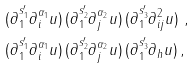Convert formula to latex. <formula><loc_0><loc_0><loc_500><loc_500>& ( \partial _ { 1 } ^ { s ^ { \prime } _ { 1 } } \partial _ { i } ^ { \alpha _ { 1 } } u ) \, ( \partial _ { 1 } ^ { s ^ { \prime } _ { 2 } } \partial _ { j } ^ { \alpha _ { 2 } } u ) \, ( \partial _ { 1 } ^ { s ^ { \prime } _ { 3 } } \partial ^ { 2 } _ { i j } u ) \ , \\ & ( \partial _ { 1 } ^ { s ^ { \prime } _ { 1 } } \partial _ { i } ^ { \alpha _ { 1 } } u ) \, ( \partial _ { 1 } ^ { s ^ { \prime } _ { 2 } } \partial _ { j } ^ { \alpha _ { 2 } } u ) \, ( \partial _ { 1 } ^ { s ^ { \prime } _ { 3 } } \partial _ { h } u ) \, ,</formula> 